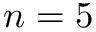Convert formula to latex. <formula><loc_0><loc_0><loc_500><loc_500>n = 5</formula> 